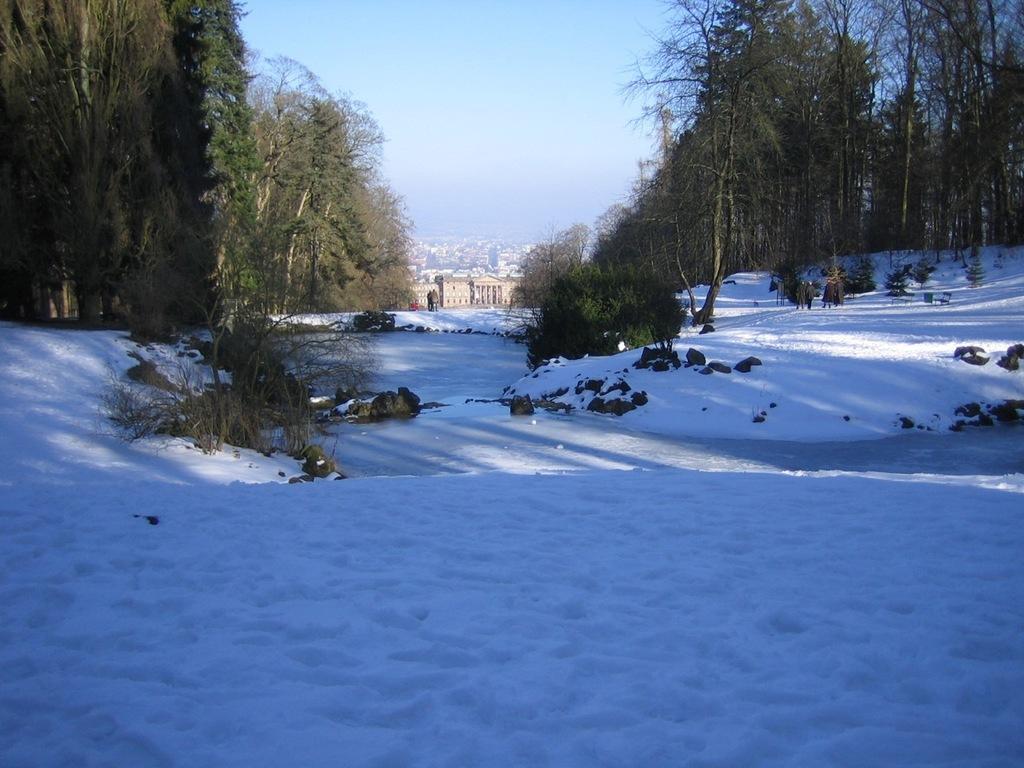Please provide a concise description of this image. In this image we can see snow on the land. In the middle of the image, we can see trees. At the top of the image, we can see the sky. In the background, we can see the buildings. 